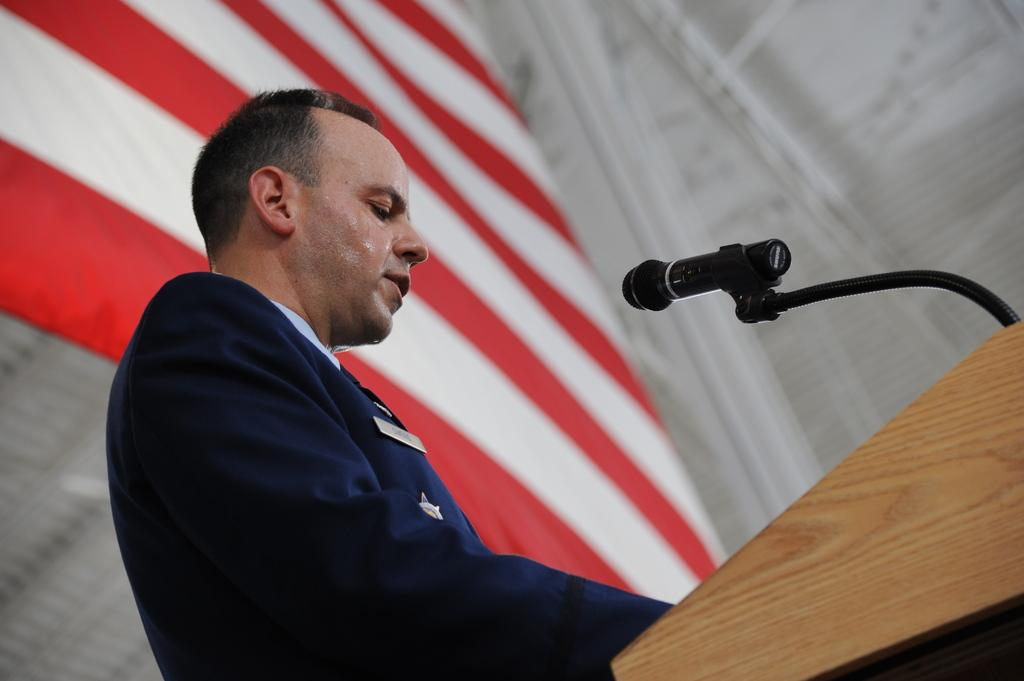What is the man in the image doing? The man is standing in the image. Where is the man located in relation to the podium? The man is in front of a podium. What is on the podium? There is a microphone on the podium. What can be seen in the banner-wise in the image? There is a white and red color banner in the image. What color is the background of the image? The background of the image is white. Where is the nest located in the image? There is no nest present in the image. What is the value of the quarter in the image? There is no quarter present in the image. 